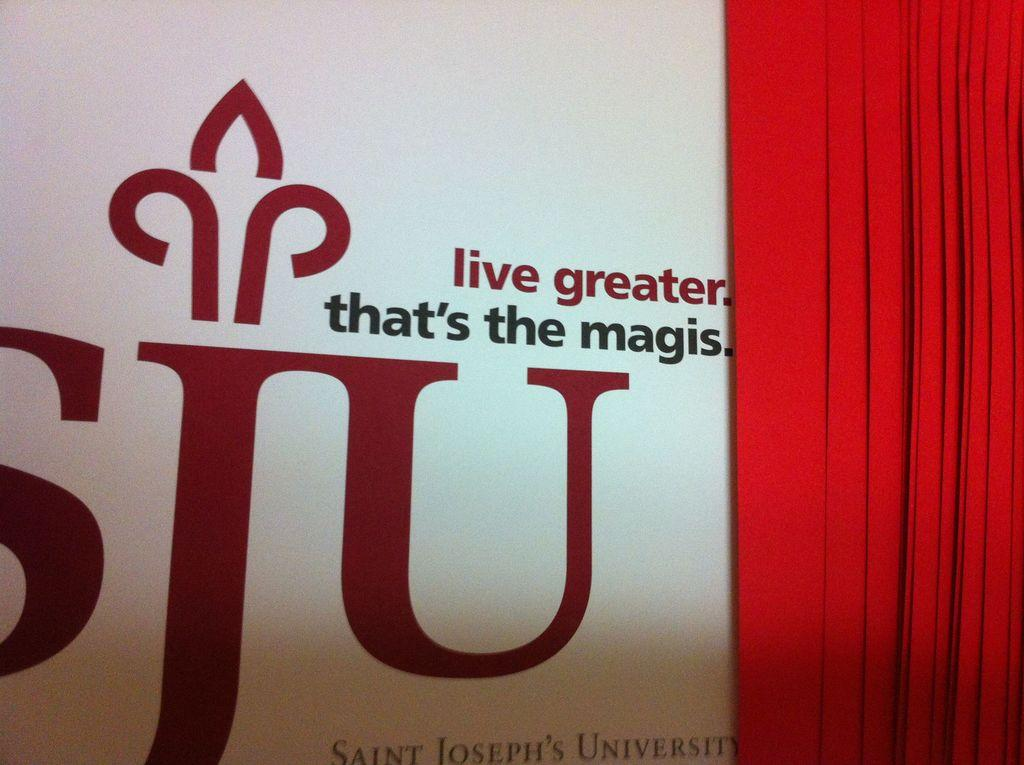<image>
Provide a brief description of the given image. A large board that has the initials SJU in red font. 